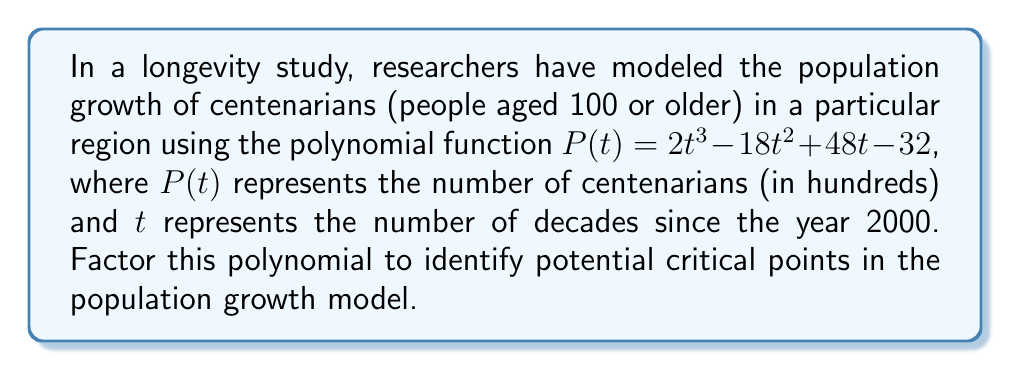Show me your answer to this math problem. To factor this polynomial, we'll follow these steps:

1) First, let's check if there's a common factor:
   $P(t) = 2t^3 - 18t^2 + 48t - 32$
   There's no common factor for all terms.

2) This is a cubic polynomial. Let's try to find a root by testing some factors of the constant term (-32). Possible factors are ±1, ±2, ±4, ±8, ±16, ±32.

3) Using synthetic division, we find that 2 is a root:

   $$
   \begin{array}{r}
   2 | \enspace 2 \enspace -18 \enspace 48 \enspace -32 \\
   \enspace \enspace \underline{4 \enspace -28 \enspace 40} \\
   2 \enspace -14 \enspace 20 \enspace 0
   \end{array}
   $$

4) So, $(t-2)$ is a factor. We can now write:
   $P(t) = (t-2)(2t^2 - 14t + 20)$

5) Now we need to factor the quadratic term $2t^2 - 14t + 20$. Let's use the quadratic formula:
   
   $$t = \frac{-b \pm \sqrt{b^2 - 4ac}}{2a} = \frac{14 \pm \sqrt{196 - 160}}{4} = \frac{14 \pm 6}{4}$$

6) This gives us $t = 5$ or $t = 2.5$

7) Therefore, we can factor the quadratic as:
   $2t^2 - 14t + 20 = 2(t-5)(t-2.5)$

8) Putting it all together:
   $P(t) = 2(t-2)(t-5)(t-2.5)$
Answer: $P(t) = 2(t-2)(t-5)(t-2.5)$ 